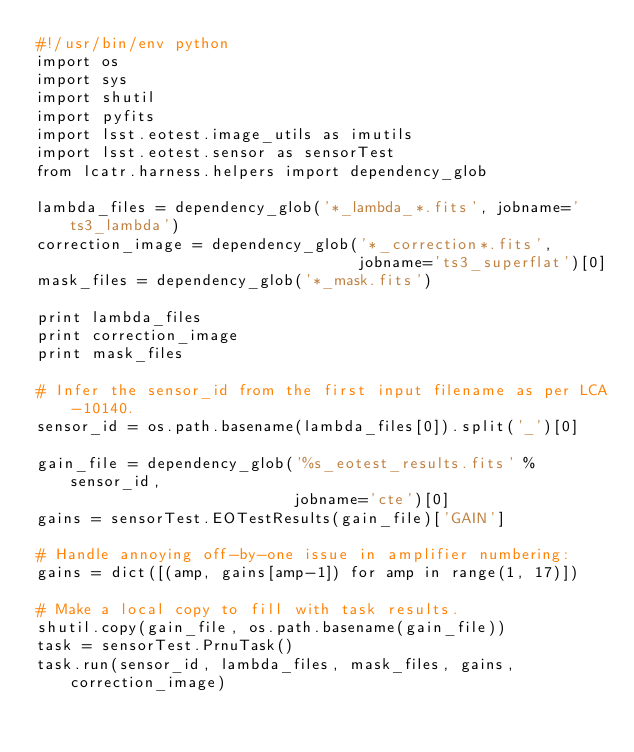Convert code to text. <code><loc_0><loc_0><loc_500><loc_500><_Python_>#!/usr/bin/env python
import os
import sys
import shutil
import pyfits
import lsst.eotest.image_utils as imutils
import lsst.eotest.sensor as sensorTest
from lcatr.harness.helpers import dependency_glob

lambda_files = dependency_glob('*_lambda_*.fits', jobname='ts3_lambda')
correction_image = dependency_glob('*_correction*.fits',
                                   jobname='ts3_superflat')[0]
mask_files = dependency_glob('*_mask.fits')

print lambda_files
print correction_image
print mask_files

# Infer the sensor_id from the first input filename as per LCA-10140.
sensor_id = os.path.basename(lambda_files[0]).split('_')[0]

gain_file = dependency_glob('%s_eotest_results.fits' % sensor_id,
                            jobname='cte')[0]
gains = sensorTest.EOTestResults(gain_file)['GAIN']

# Handle annoying off-by-one issue in amplifier numbering:
gains = dict([(amp, gains[amp-1]) for amp in range(1, 17)])

# Make a local copy to fill with task results.
shutil.copy(gain_file, os.path.basename(gain_file))
task = sensorTest.PrnuTask()
task.run(sensor_id, lambda_files, mask_files, gains, correction_image)
</code> 